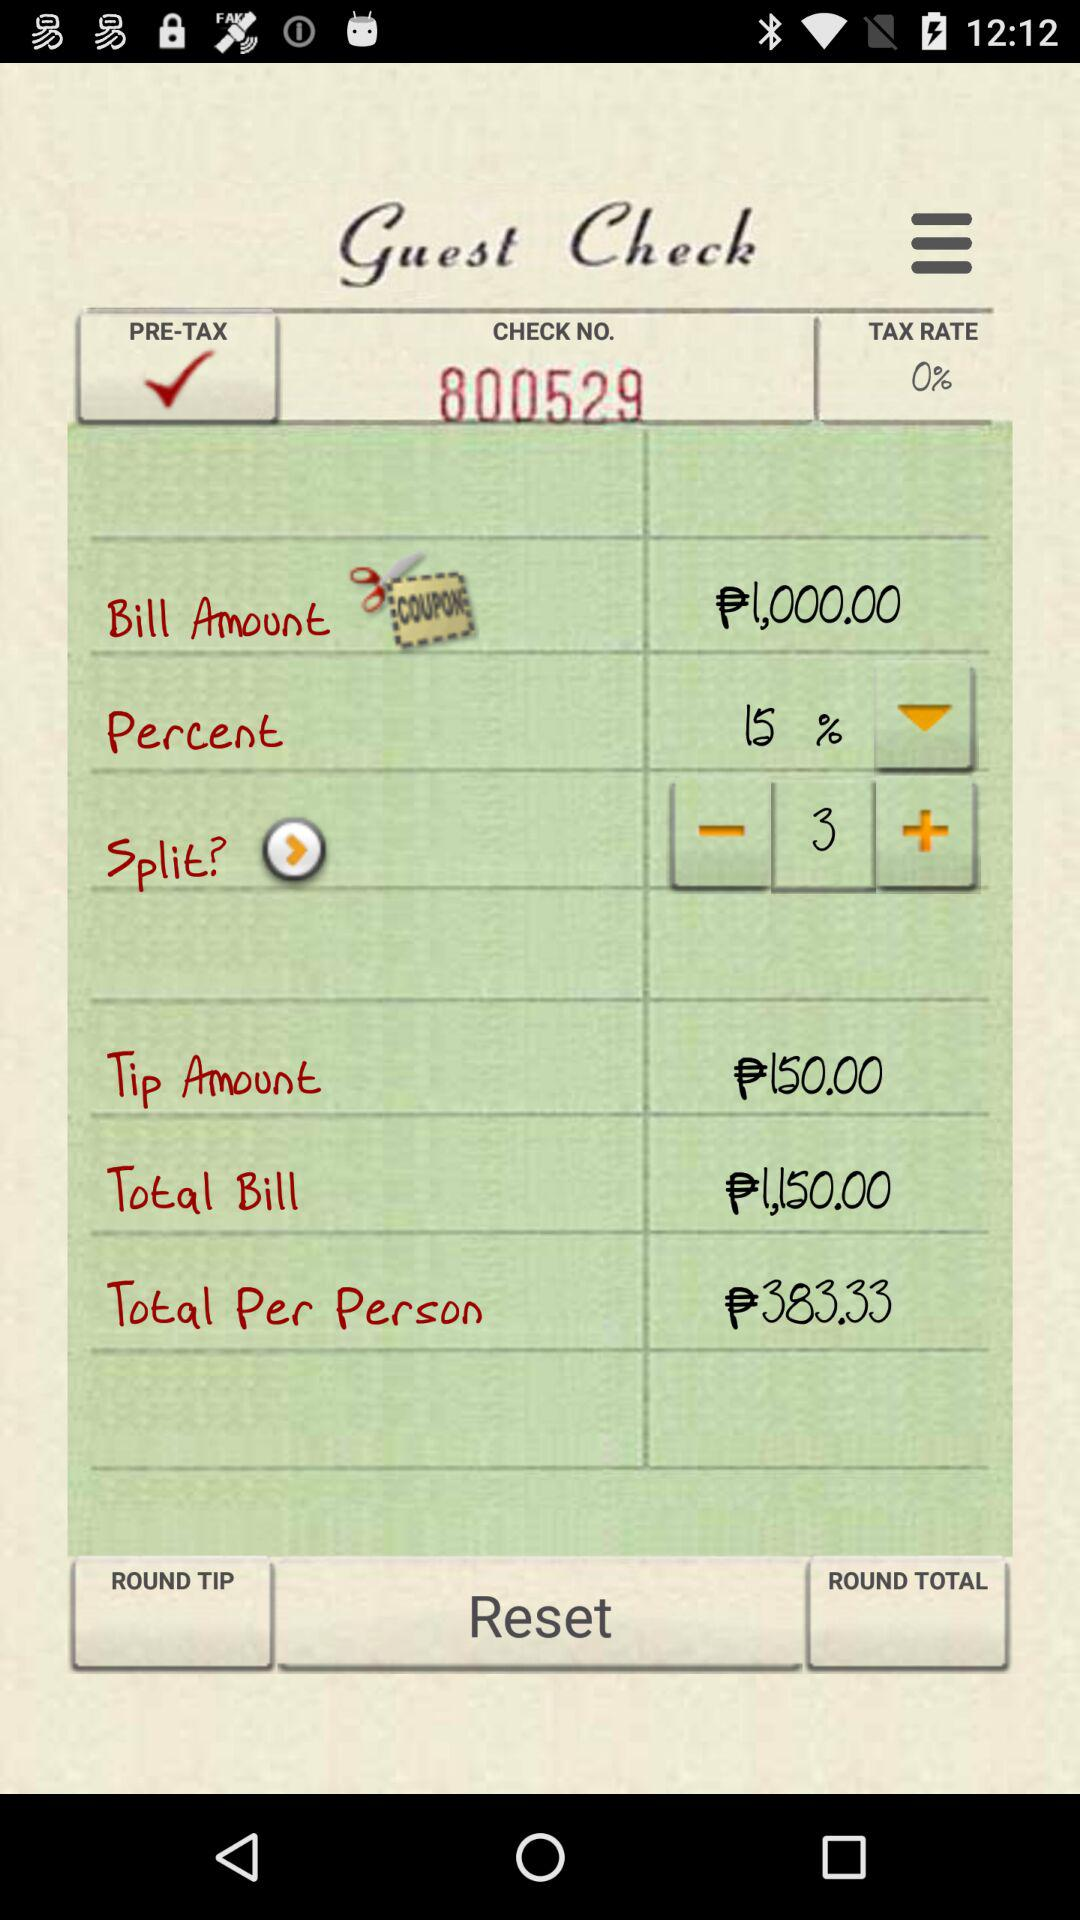What is the check number? The check number is 800529. 